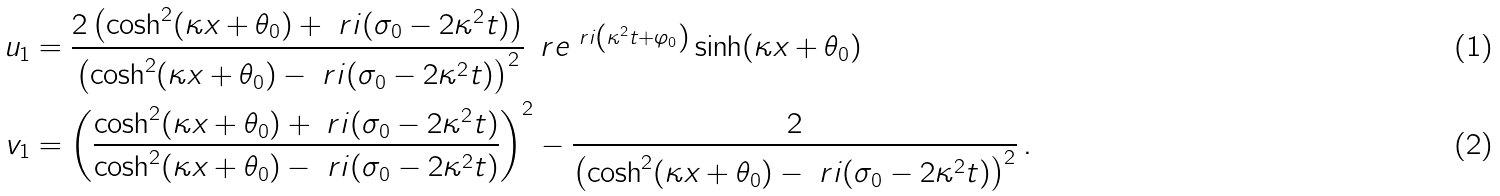Convert formula to latex. <formula><loc_0><loc_0><loc_500><loc_500>u _ { 1 } & = \frac { 2 \left ( \cosh ^ { 2 } ( \kappa x + \theta _ { 0 } ) + \ r i ( \sigma _ { 0 } - 2 \kappa ^ { 2 } t ) \right ) } { \left ( \cosh ^ { 2 } ( \kappa x + \theta _ { 0 } ) - \ r i ( \sigma _ { 0 } - 2 \kappa ^ { 2 } t ) \right ) ^ { 2 } } \, \ r e ^ { \ r i \left ( \kappa ^ { 2 } t + \varphi _ { 0 } \right ) } \sinh ( \kappa x + \theta _ { 0 } ) \\ v _ { 1 } & = \left ( \frac { \cosh ^ { 2 } ( \kappa x + \theta _ { 0 } ) + \ r i ( \sigma _ { 0 } - 2 \kappa ^ { 2 } t ) } { \cosh ^ { 2 } ( \kappa x + \theta _ { 0 } ) - \ r i ( \sigma _ { 0 } - 2 \kappa ^ { 2 } t ) } \right ) ^ { 2 } - \frac { 2 } { \left ( \cosh ^ { 2 } ( \kappa x + \theta _ { 0 } ) - \ r i ( \sigma _ { 0 } - 2 \kappa ^ { 2 } t ) \right ) ^ { 2 } } \, .</formula> 